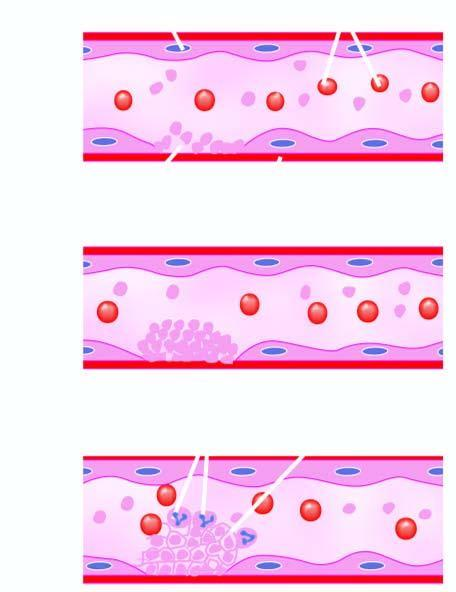what does b, endothelial injury expose?
Answer the question using a single word or phrase. Subendothelium 